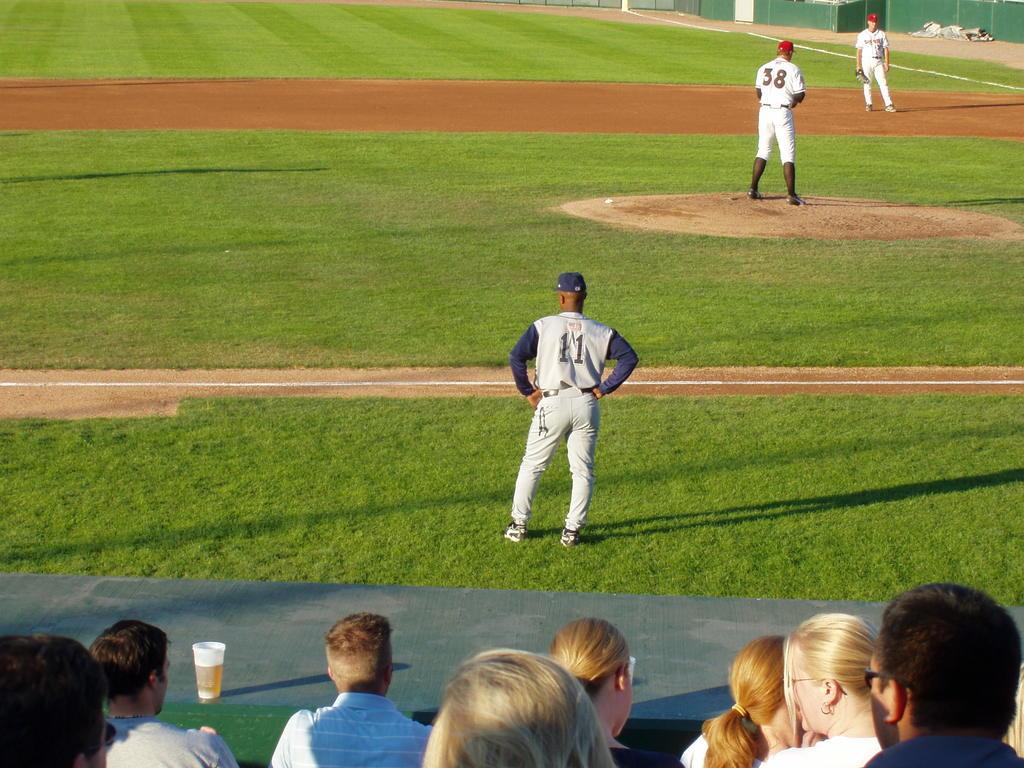What is the number of the pitcher on the mound?
Offer a terse response. 38. 